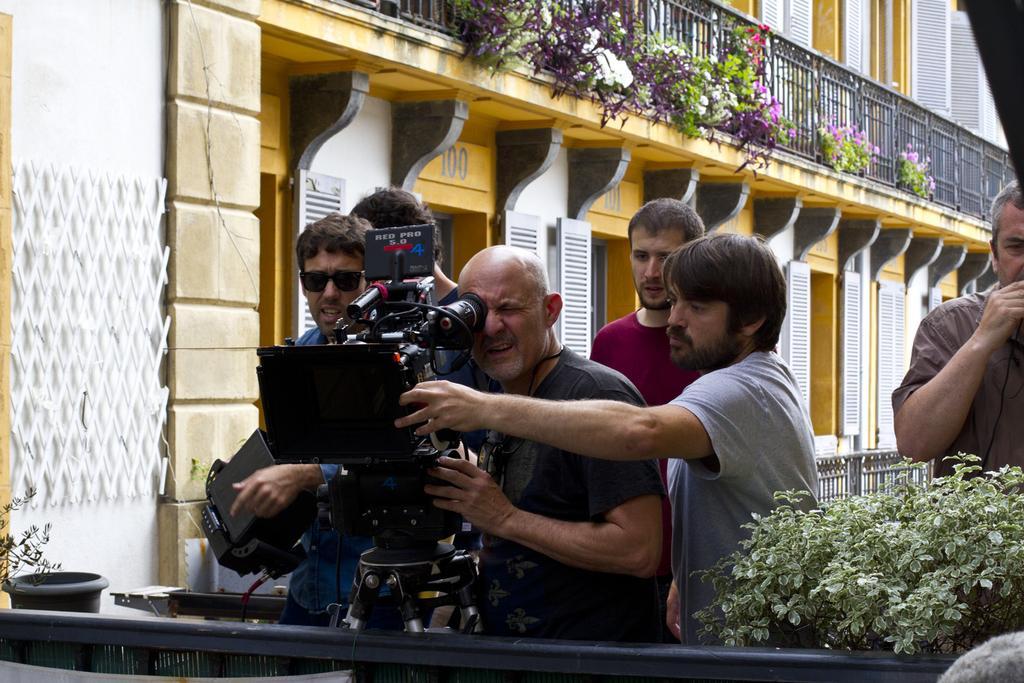Please provide a concise description of this image. In the image there are few men in the middle and center man is looking into the camera and beside them there is a plant and at the background there is a building. 